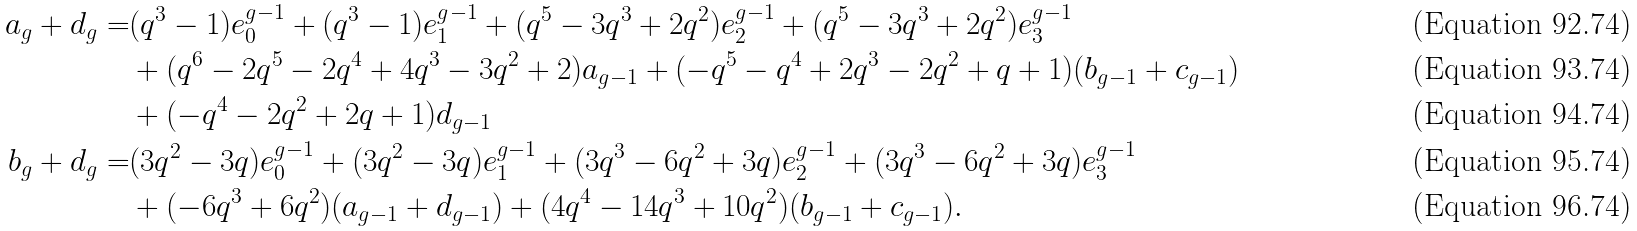Convert formula to latex. <formula><loc_0><loc_0><loc_500><loc_500>a _ { g } + d _ { g } = & ( q ^ { 3 } - 1 ) e _ { 0 } ^ { g - 1 } + ( q ^ { 3 } - 1 ) e _ { 1 } ^ { g - 1 } + ( q ^ { 5 } - 3 q ^ { 3 } + 2 q ^ { 2 } ) e _ { 2 } ^ { g - 1 } + ( q ^ { 5 } - 3 q ^ { 3 } + 2 q ^ { 2 } ) e _ { 3 } ^ { g - 1 } \\ & + ( q ^ { 6 } - 2 q ^ { 5 } - 2 q ^ { 4 } + 4 q ^ { 3 } - 3 q ^ { 2 } + 2 ) a _ { g - 1 } + ( - q ^ { 5 } - q ^ { 4 } + 2 q ^ { 3 } - 2 q ^ { 2 } + q + 1 ) ( b _ { g - 1 } + c _ { g - 1 } ) \\ & + ( - q ^ { 4 } - 2 q ^ { 2 } + 2 q + 1 ) d _ { g - 1 } \\ b _ { g } + d _ { g } = & ( 3 q ^ { 2 } - 3 q ) e _ { 0 } ^ { g - 1 } + ( 3 q ^ { 2 } - 3 q ) e _ { 1 } ^ { g - 1 } + ( 3 q ^ { 3 } - 6 q ^ { 2 } + 3 q ) e _ { 2 } ^ { g - 1 } + ( 3 q ^ { 3 } - 6 q ^ { 2 } + 3 q ) e _ { 3 } ^ { g - 1 } \\ & + ( - 6 q ^ { 3 } + 6 q ^ { 2 } ) ( a _ { g - 1 } + d _ { g - 1 } ) + ( 4 q ^ { 4 } - 1 4 q ^ { 3 } + 1 0 q ^ { 2 } ) ( b _ { g - 1 } + c _ { g - 1 } ) .</formula> 